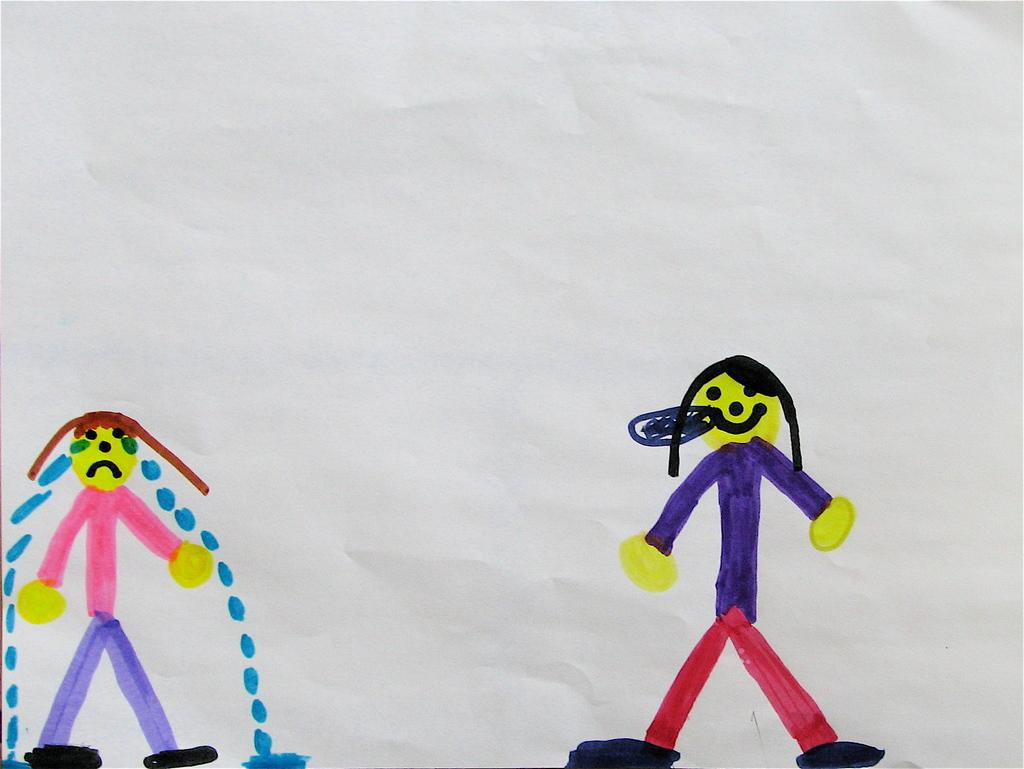What type of artwork is depicted in the image? There are cartoon paintings in the image. Who or what are the subjects of the paintings? The paintings are of persons. What is the background of the paintings? The paintings are on a white paper. Can you see a boat in any of the cartoon paintings? There is no boat present in any of the cartoon paintings in the image. What type of lace is used to frame the paintings? There is no lace present in the image; the paintings are on a white paper. 